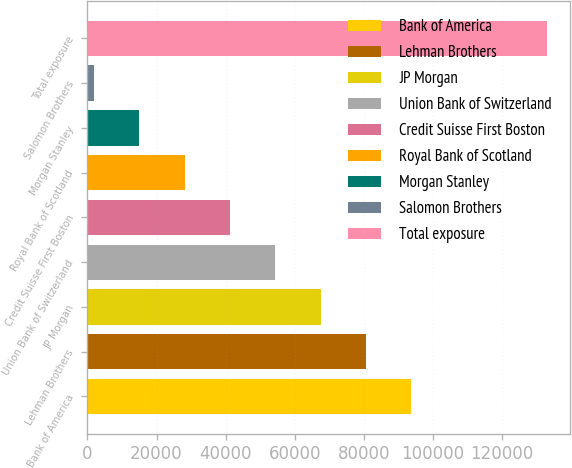Convert chart. <chart><loc_0><loc_0><loc_500><loc_500><bar_chart><fcel>Bank of America<fcel>Lehman Brothers<fcel>JP Morgan<fcel>Union Bank of Switzerland<fcel>Credit Suisse First Boston<fcel>Royal Bank of Scotland<fcel>Morgan Stanley<fcel>Salomon Brothers<fcel>Total exposure<nl><fcel>93757.1<fcel>80640.8<fcel>67524.5<fcel>54408.2<fcel>41291.9<fcel>28175.6<fcel>15059.3<fcel>1943<fcel>133106<nl></chart> 